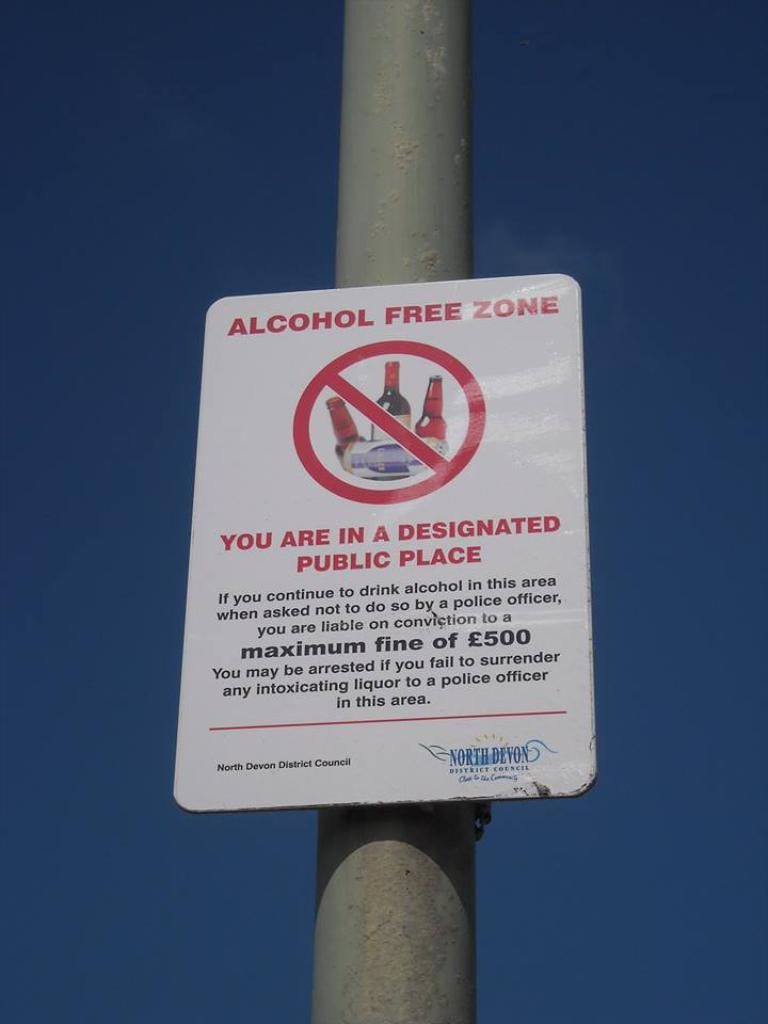Provide a one-sentence caption for the provided image. A alcohol free zone sign on a pole outside. 